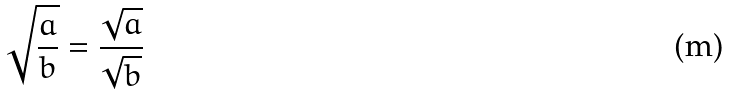<formula> <loc_0><loc_0><loc_500><loc_500>\sqrt { \frac { a } { b } } = \frac { \sqrt { a } } { \sqrt { b } }</formula> 